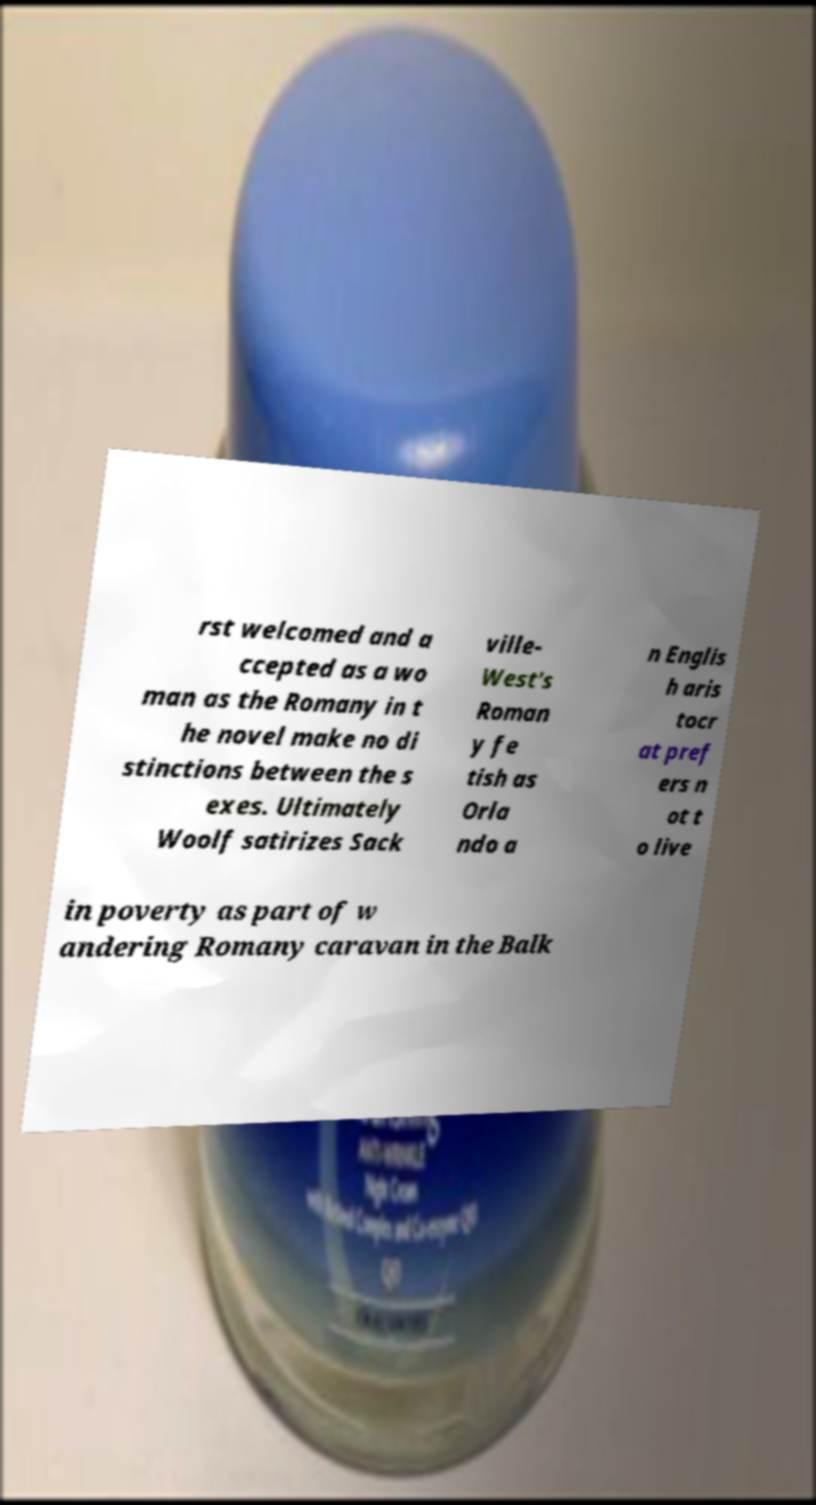Can you read and provide the text displayed in the image?This photo seems to have some interesting text. Can you extract and type it out for me? rst welcomed and a ccepted as a wo man as the Romany in t he novel make no di stinctions between the s exes. Ultimately Woolf satirizes Sack ville- West's Roman y fe tish as Orla ndo a n Englis h aris tocr at pref ers n ot t o live in poverty as part of w andering Romany caravan in the Balk 